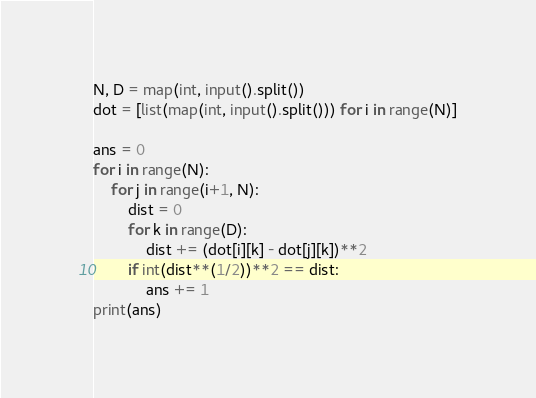Convert code to text. <code><loc_0><loc_0><loc_500><loc_500><_Python_>N, D = map(int, input().split())
dot = [list(map(int, input().split())) for i in range(N)]

ans = 0
for i in range(N):
    for j in range(i+1, N):
        dist = 0
        for k in range(D):
            dist += (dot[i][k] - dot[j][k])**2
        if int(dist**(1/2))**2 == dist:
            ans += 1
print(ans)
</code> 